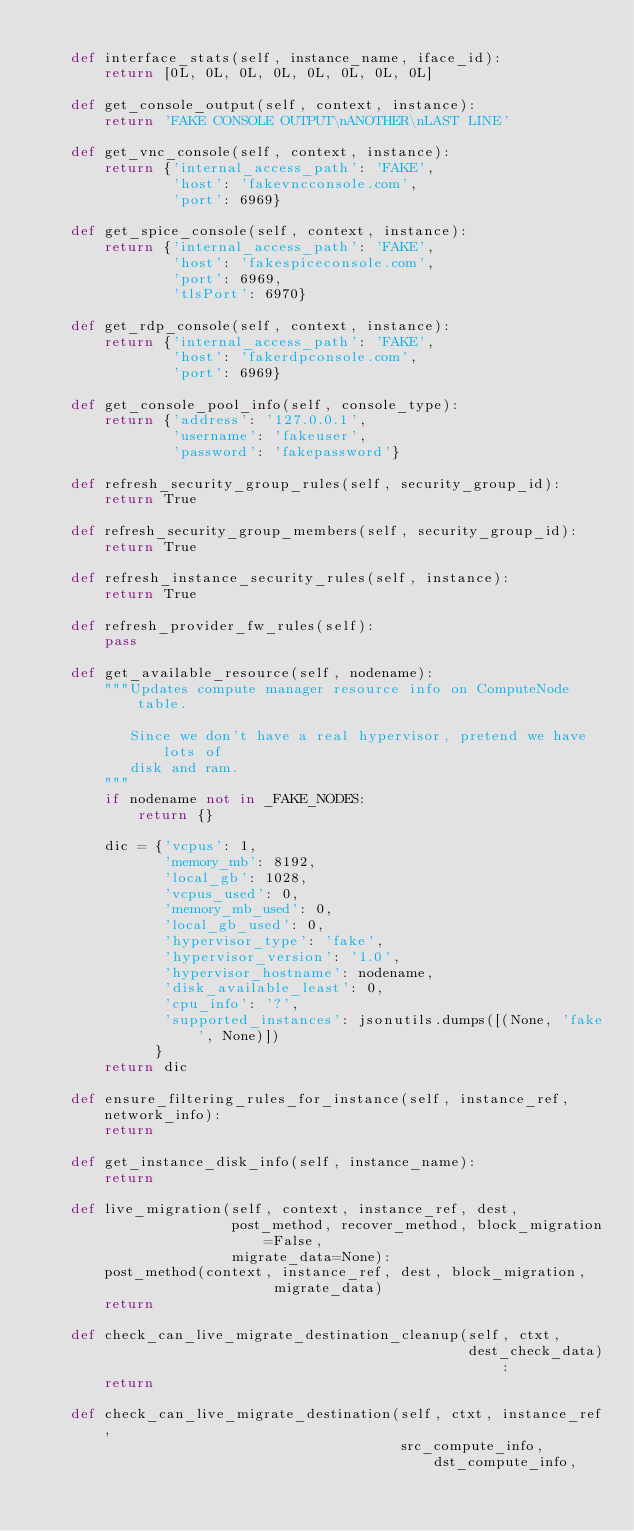<code> <loc_0><loc_0><loc_500><loc_500><_Python_>
    def interface_stats(self, instance_name, iface_id):
        return [0L, 0L, 0L, 0L, 0L, 0L, 0L, 0L]

    def get_console_output(self, context, instance):
        return 'FAKE CONSOLE OUTPUT\nANOTHER\nLAST LINE'

    def get_vnc_console(self, context, instance):
        return {'internal_access_path': 'FAKE',
                'host': 'fakevncconsole.com',
                'port': 6969}

    def get_spice_console(self, context, instance):
        return {'internal_access_path': 'FAKE',
                'host': 'fakespiceconsole.com',
                'port': 6969,
                'tlsPort': 6970}

    def get_rdp_console(self, context, instance):
        return {'internal_access_path': 'FAKE',
                'host': 'fakerdpconsole.com',
                'port': 6969}

    def get_console_pool_info(self, console_type):
        return {'address': '127.0.0.1',
                'username': 'fakeuser',
                'password': 'fakepassword'}

    def refresh_security_group_rules(self, security_group_id):
        return True

    def refresh_security_group_members(self, security_group_id):
        return True

    def refresh_instance_security_rules(self, instance):
        return True

    def refresh_provider_fw_rules(self):
        pass

    def get_available_resource(self, nodename):
        """Updates compute manager resource info on ComputeNode table.

           Since we don't have a real hypervisor, pretend we have lots of
           disk and ram.
        """
        if nodename not in _FAKE_NODES:
            return {}

        dic = {'vcpus': 1,
               'memory_mb': 8192,
               'local_gb': 1028,
               'vcpus_used': 0,
               'memory_mb_used': 0,
               'local_gb_used': 0,
               'hypervisor_type': 'fake',
               'hypervisor_version': '1.0',
               'hypervisor_hostname': nodename,
               'disk_available_least': 0,
               'cpu_info': '?',
               'supported_instances': jsonutils.dumps([(None, 'fake', None)])
              }
        return dic

    def ensure_filtering_rules_for_instance(self, instance_ref, network_info):
        return

    def get_instance_disk_info(self, instance_name):
        return

    def live_migration(self, context, instance_ref, dest,
                       post_method, recover_method, block_migration=False,
                       migrate_data=None):
        post_method(context, instance_ref, dest, block_migration,
                            migrate_data)
        return

    def check_can_live_migrate_destination_cleanup(self, ctxt,
                                                   dest_check_data):
        return

    def check_can_live_migrate_destination(self, ctxt, instance_ref,
                                           src_compute_info, dst_compute_info,</code> 